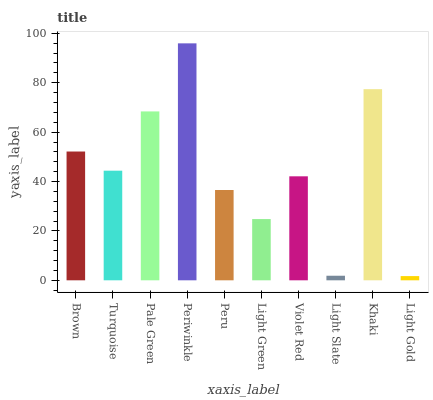Is Turquoise the minimum?
Answer yes or no. No. Is Turquoise the maximum?
Answer yes or no. No. Is Brown greater than Turquoise?
Answer yes or no. Yes. Is Turquoise less than Brown?
Answer yes or no. Yes. Is Turquoise greater than Brown?
Answer yes or no. No. Is Brown less than Turquoise?
Answer yes or no. No. Is Turquoise the high median?
Answer yes or no. Yes. Is Violet Red the low median?
Answer yes or no. Yes. Is Light Slate the high median?
Answer yes or no. No. Is Pale Green the low median?
Answer yes or no. No. 